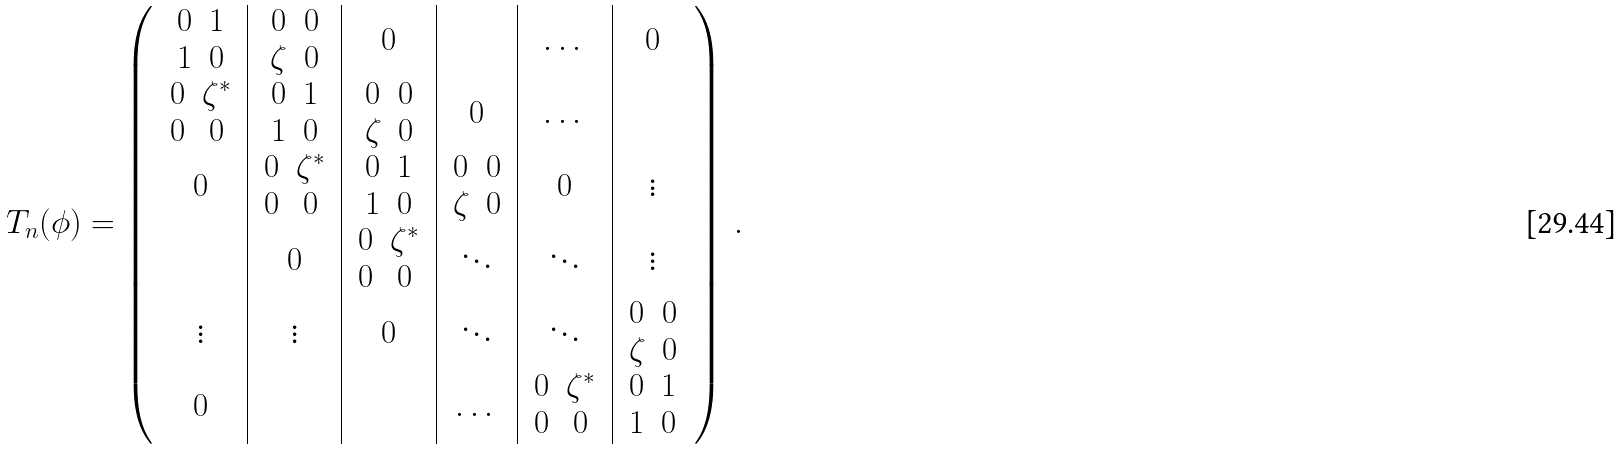Convert formula to latex. <formula><loc_0><loc_0><loc_500><loc_500>T _ { n } ( \phi ) = \left ( \begin{array} { c | c | c | c | c | c } \begin{array} { c c } 0 & 1 \\ 1 & 0 \end{array} & \begin{array} { c c } 0 & 0 \\ \zeta & 0 \end{array} & 0 & & \dots & 0 \\ \begin{array} { c c } 0 & \zeta ^ { * } \\ 0 & 0 \end{array} & \begin{array} { c c } 0 & 1 \\ 1 & 0 \end{array} & \begin{array} { c c } 0 & 0 \\ \zeta & 0 \end{array} & 0 & \dots & \\ 0 & \begin{array} { c c } 0 & \zeta ^ { * } \\ 0 & 0 \end{array} & \begin{array} { c c } 0 & 1 \\ 1 & 0 \end{array} & \begin{array} { c c } 0 & 0 \\ \zeta & 0 \end{array} & 0 & \vdots \\ & 0 & \begin{array} { c c } 0 & \zeta ^ { * } \\ 0 & 0 \end{array} & \ddots & \ddots & \vdots \\ \vdots & \vdots & 0 & \ddots & \ddots & \begin{array} { c c } 0 & 0 \\ \zeta & 0 \end{array} \\ 0 & & & \dots & \begin{array} { c c } 0 & \zeta ^ { * } \\ 0 & 0 \end{array} & \begin{array} { c c } 0 & 1 \\ 1 & 0 \end{array} \end{array} \right ) \, .</formula> 